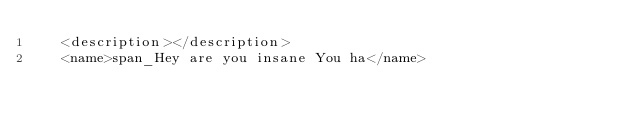Convert code to text. <code><loc_0><loc_0><loc_500><loc_500><_Rust_>   <description></description>
   <name>span_Hey are you insane You ha</name></code> 